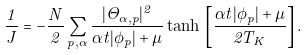Convert formula to latex. <formula><loc_0><loc_0><loc_500><loc_500>\frac { 1 } { J } = - \frac { N } { 2 } \sum _ { p , \alpha } \frac { | \Theta _ { \alpha , p } | ^ { 2 } } { \alpha t | \phi _ { p } | + \mu } \tanh \, \left [ \frac { \alpha t | \phi _ { p } | + \mu } { 2 T _ { K } } \right ] .</formula> 